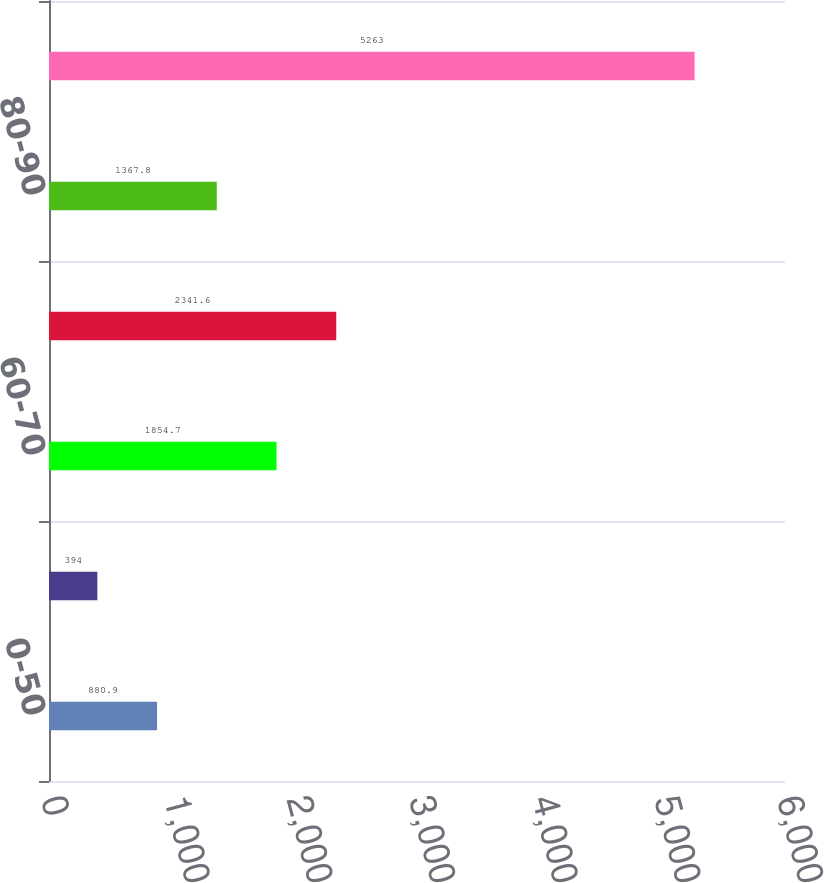Convert chart to OTSL. <chart><loc_0><loc_0><loc_500><loc_500><bar_chart><fcel>0-50<fcel>50-60<fcel>60-70<fcel>70-80<fcel>80-90<fcel>Total commercial mortgage<nl><fcel>880.9<fcel>394<fcel>1854.7<fcel>2341.6<fcel>1367.8<fcel>5263<nl></chart> 